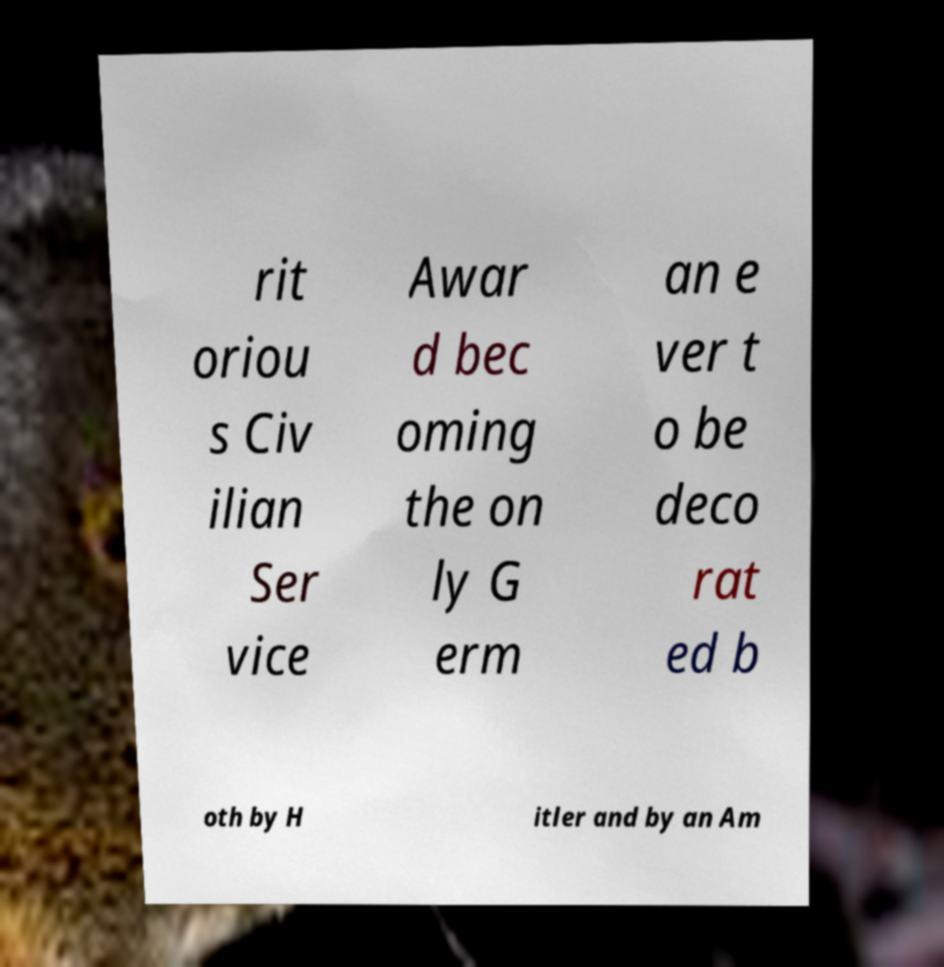Could you assist in decoding the text presented in this image and type it out clearly? rit oriou s Civ ilian Ser vice Awar d bec oming the on ly G erm an e ver t o be deco rat ed b oth by H itler and by an Am 